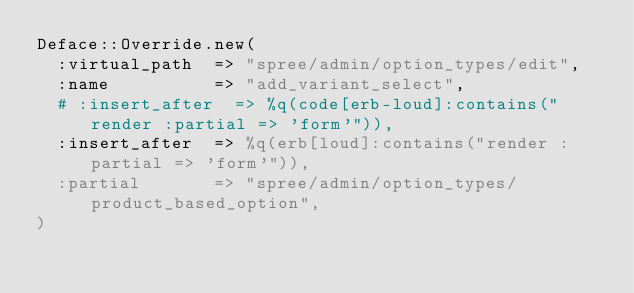Convert code to text. <code><loc_0><loc_0><loc_500><loc_500><_Ruby_>Deface::Override.new(
  :virtual_path  => "spree/admin/option_types/edit",
  :name          => "add_variant_select",
  # :insert_after  => %q(code[erb-loud]:contains("render :partial => 'form'")),
  :insert_after  => %q(erb[loud]:contains("render :partial => 'form'")),
  :partial       => "spree/admin/option_types/product_based_option",
)

</code> 